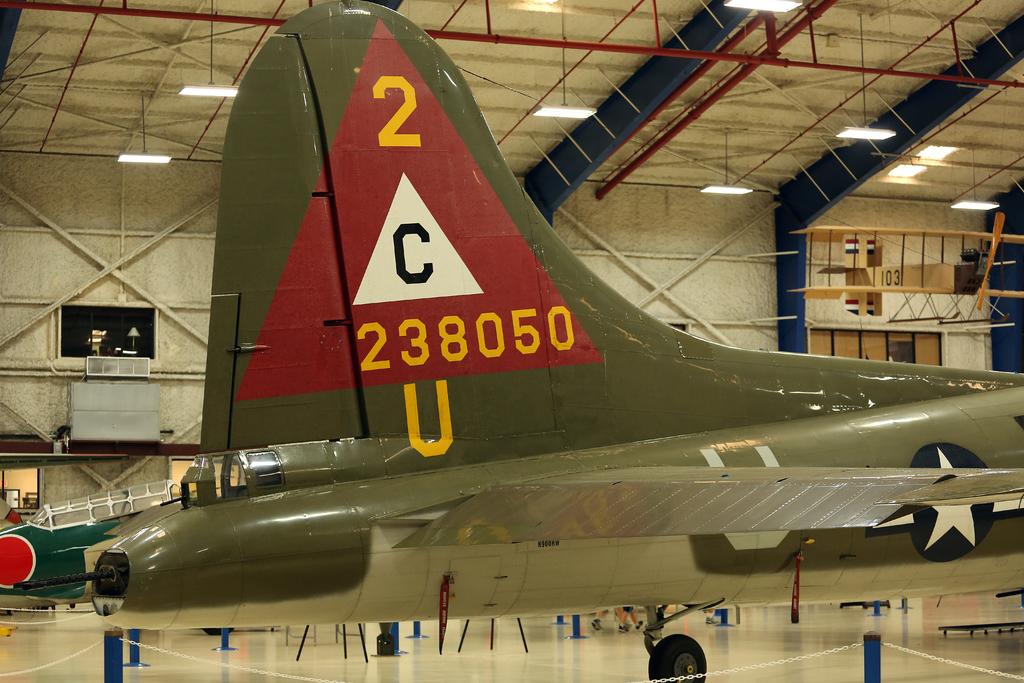What letter is on the plane's tail?
Ensure brevity in your answer.  C. What number is above the letter "c?"?
Your response must be concise. 2. 